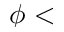Convert formula to latex. <formula><loc_0><loc_0><loc_500><loc_500>\phi <</formula> 